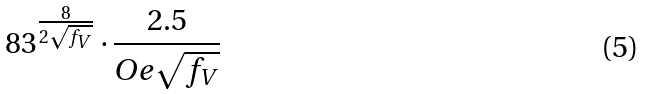Convert formula to latex. <formula><loc_0><loc_0><loc_500><loc_500>8 3 ^ { \frac { 8 } { 2 \sqrt { f _ { V } } } } \cdot \frac { 2 . 5 } { O e \sqrt { f _ { V } } }</formula> 